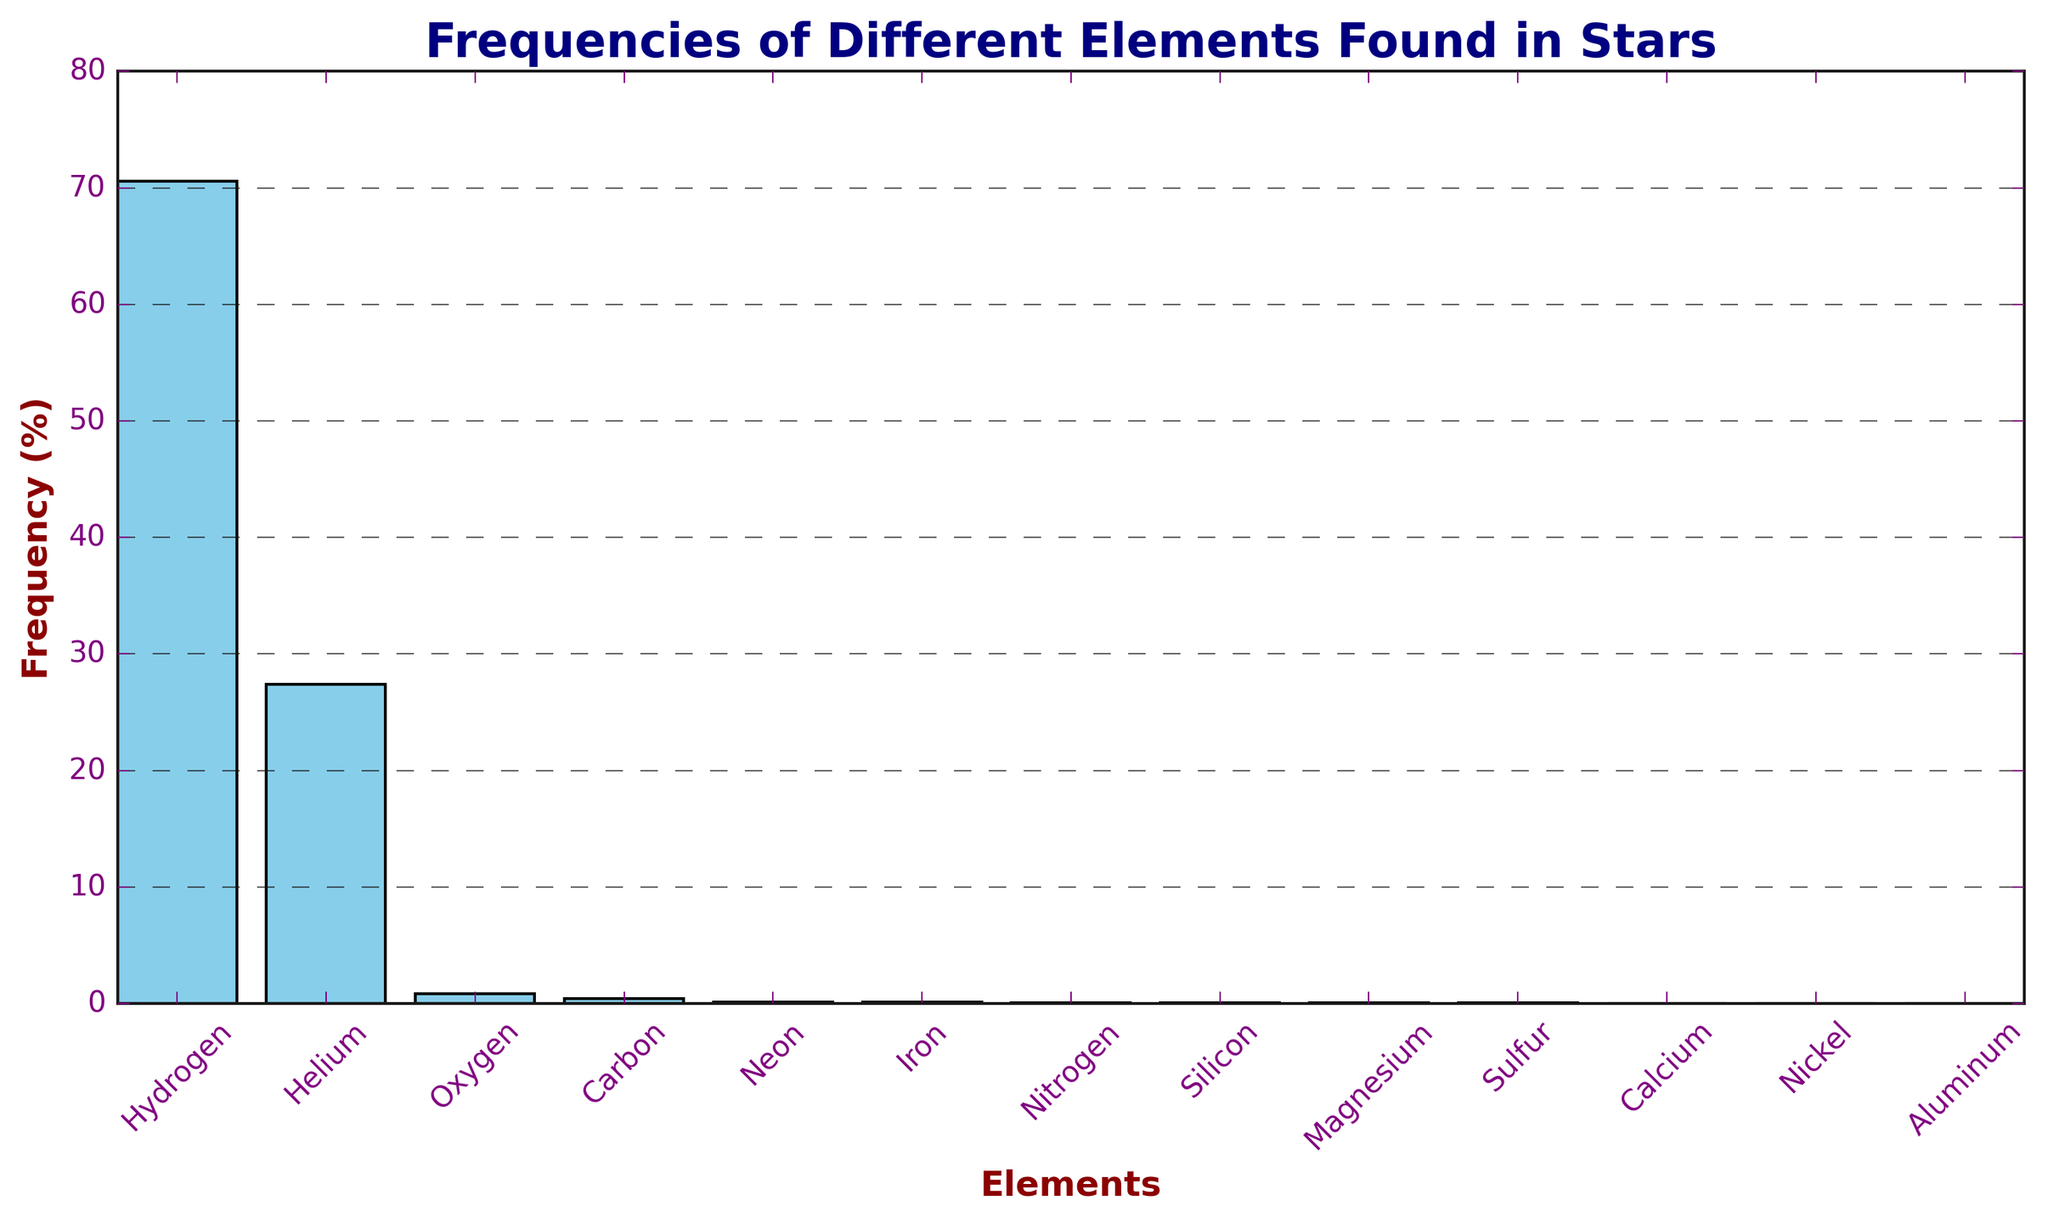What is the most abundant element found in stars? Observing the bars in the histogram, the tallest bar represents the element with the highest frequency. In this case, the bar for Hydrogen is the tallest.
Answer: Hydrogen What is the combined frequency of Oxygen, Carbon, and Neon? To find the combined frequency, add the frequencies of Oxygen (0.86%), Carbon (0.40%), and Neon (0.13%). The sum is 0.86 + 0.40 + 0.13 = 1.39%.
Answer: 1.39% Which element has a higher frequency, Iron or Nitrogen? Compare the heights of the bars for Iron and Nitrogen. The bar for Iron shows a frequency of 0.11%, while the bar for Nitrogen shows a lower frequency of 0.09%.
Answer: Iron What is the average frequency of the elements that have a frequency above 1%? Only Hydrogen (70.6%) and Helium (27.4%) have frequencies above 1%. To find the average, sum these frequencies and divide by 2: (70.6 + 27.4) / 2 = 49%.
Answer: 49% What is the difference in frequency between Hydrogen and Helium? Subtract the frequency of Helium from the frequency of Hydrogen, which is 70.6% - 27.4%. This equals 43.2%.
Answer: 43.2% Which element has the lowest frequency? Observing the bars, the shortest ones are for Nickel and Aluminum, each with a frequency of 0.01%.
Answer: Nickel or Aluminum Is the frequency of Silicon more or less than double the frequency of Sulfur? The frequency of Silicon is 0.07%, and double the frequency of Sulfur (0.04%) is 0.08%. Since 0.07% is less than 0.08%, Silicon's frequency is less than double that of Sulfur.
Answer: Less How many elements have a frequency less than 0.10%? By counting the bars with frequencies less than 0.10%, we identify seven elements: Neon (0.13%), Iron (0.11%), Nitrogen (0.09%), Silicon (0.07%), Magnesium (0.06%), Sulfur (0.04%), Calcium (0.03%), Nickel (0.01%), and Aluminum (0.01%). However, only seven of these have frequencies below 0.10%.
Answer: 7 